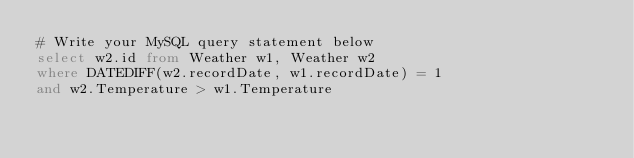Convert code to text. <code><loc_0><loc_0><loc_500><loc_500><_SQL_># Write your MySQL query statement below
select w2.id from Weather w1, Weather w2
where DATEDIFF(w2.recordDate, w1.recordDate) = 1
and w2.Temperature > w1.Temperature</code> 